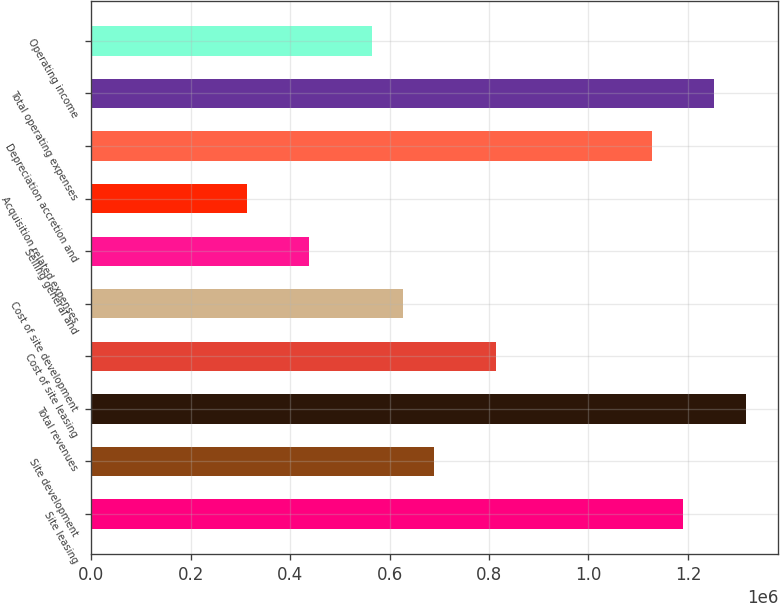Convert chart to OTSL. <chart><loc_0><loc_0><loc_500><loc_500><bar_chart><fcel>Site leasing<fcel>Site development<fcel>Total revenues<fcel>Cost of site leasing<fcel>Cost of site development<fcel>Selling general and<fcel>Acquisition related expenses<fcel>Depreciation accretion and<fcel>Total operating expenses<fcel>Operating income<nl><fcel>1.19057e+06<fcel>689281<fcel>1.3159e+06<fcel>814604<fcel>626619<fcel>438634<fcel>313310<fcel>1.12791e+06<fcel>1.25324e+06<fcel>563957<nl></chart> 